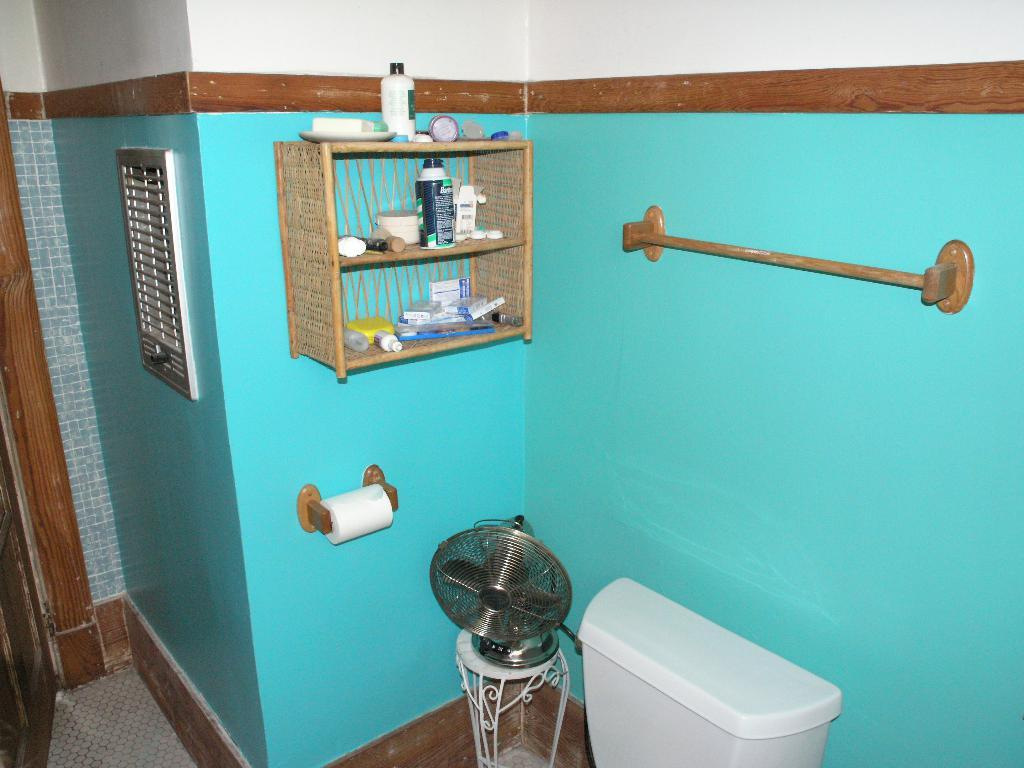What is located at the bottom of the image? There is a flush tank at the bottom of the image. What is placed on a stool in the image? There is a table fan on a stool in the image. What can be seen besides the flush tank and table fan? There is a bottle, small boxes, and a plate in the image. Are there any objects on a stand on the wall in the image? Yes, there are other objects on a stand on the wall in the image. What is visible on the left side of the image? There is a door on the left side of the image. Can you tell me how many leaves are on the table fan in the image? There are no leaves present in the image, as it features a table fan on a stool. What type of store is visible in the image? There is no store visible in the image; it contains a flush tank, table fan, bottle, small boxes, plate, and objects on a stand on the wall. 